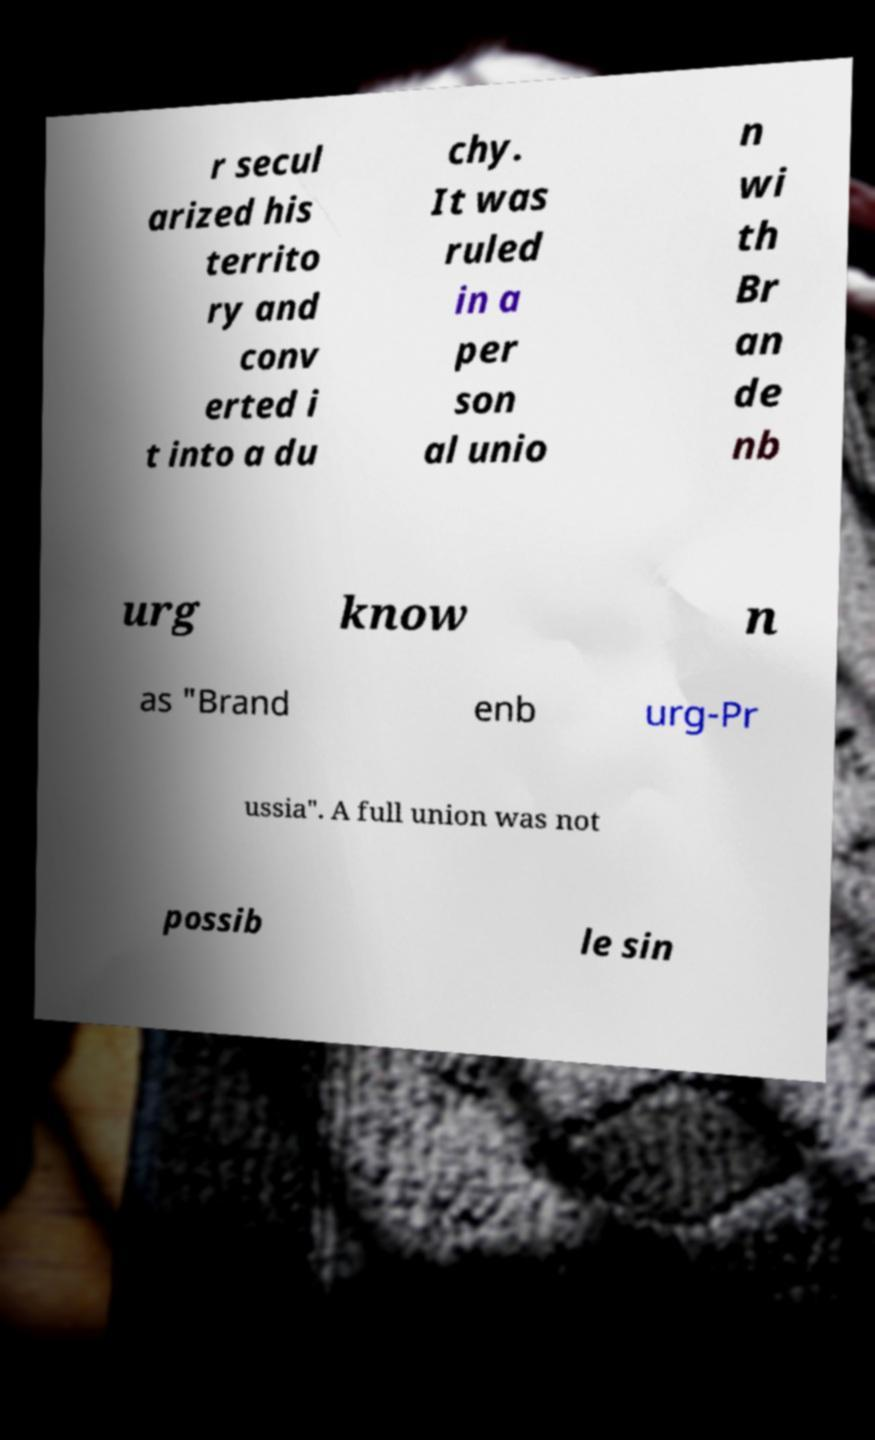Please identify and transcribe the text found in this image. r secul arized his territo ry and conv erted i t into a du chy. It was ruled in a per son al unio n wi th Br an de nb urg know n as "Brand enb urg-Pr ussia". A full union was not possib le sin 